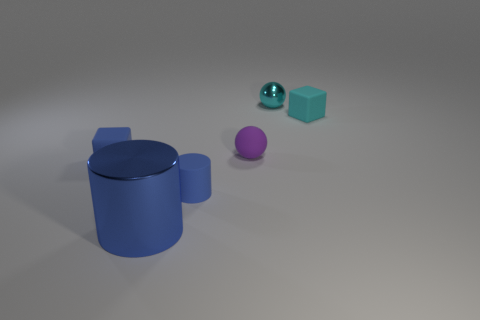Add 4 big matte spheres. How many objects exist? 10 Subtract all cylinders. How many objects are left? 4 Add 1 tiny cyan spheres. How many tiny cyan spheres exist? 2 Subtract 0 cyan cylinders. How many objects are left? 6 Subtract all tiny brown metal cubes. Subtract all tiny cylinders. How many objects are left? 5 Add 3 purple rubber spheres. How many purple rubber spheres are left? 4 